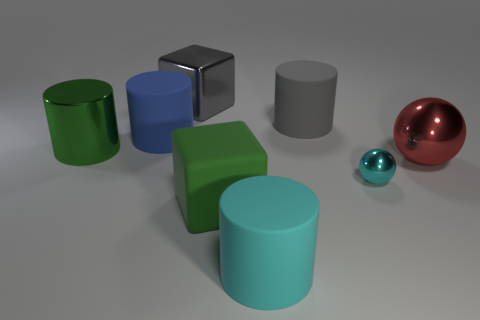Subtract 1 cylinders. How many cylinders are left? 3 Subtract all blue cylinders. How many cylinders are left? 3 Add 1 tiny things. How many objects exist? 9 Subtract all cubes. How many objects are left? 6 Add 3 big gray cubes. How many big gray cubes exist? 4 Subtract 0 purple cubes. How many objects are left? 8 Subtract all gray matte objects. Subtract all big red spheres. How many objects are left? 6 Add 8 big metal cylinders. How many big metal cylinders are left? 9 